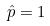Convert formula to latex. <formula><loc_0><loc_0><loc_500><loc_500>\hat { p } = 1</formula> 